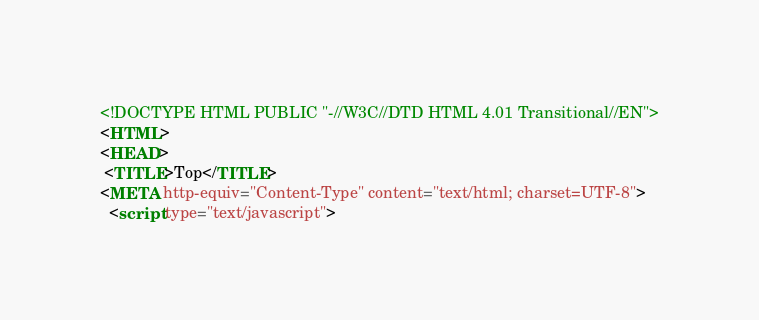<code> <loc_0><loc_0><loc_500><loc_500><_HTML_><!DOCTYPE HTML PUBLIC "-//W3C//DTD HTML 4.01 Transitional//EN">
<HTML>
<HEAD>
 <TITLE>Top</TITLE>
<META http-equiv="Content-Type" content="text/html; charset=UTF-8">
  <script type="text/javascript"></code> 